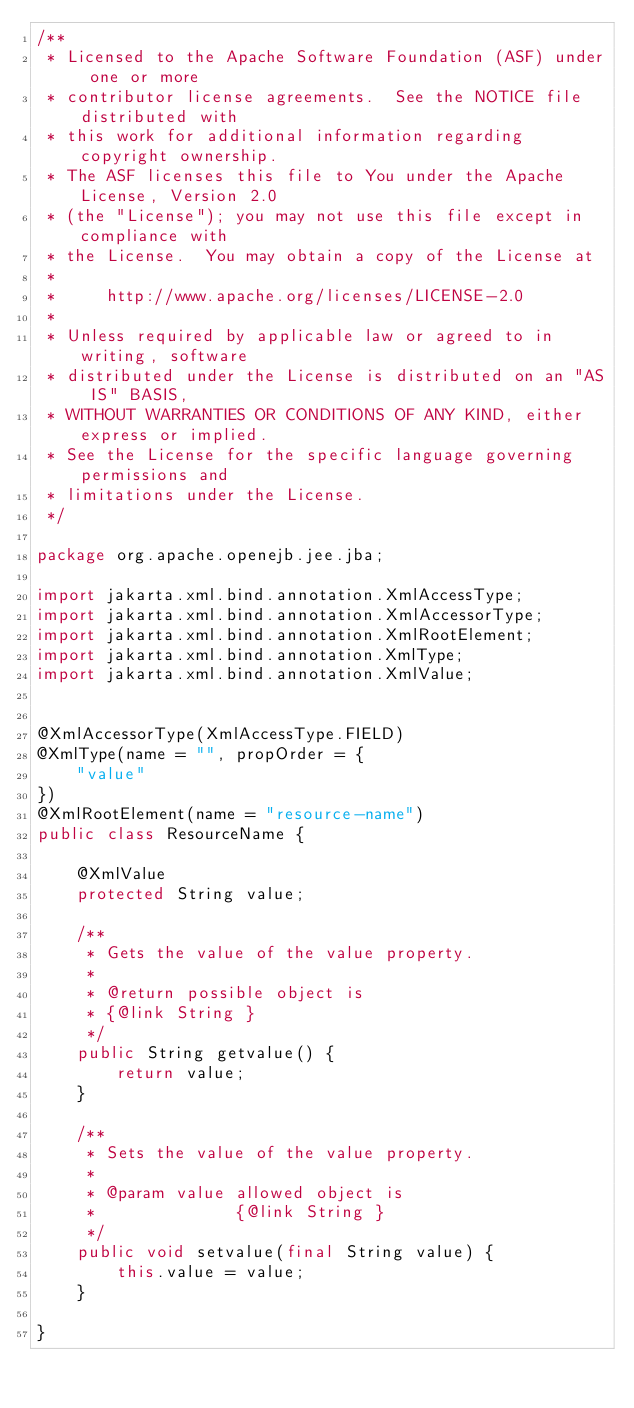Convert code to text. <code><loc_0><loc_0><loc_500><loc_500><_Java_>/**
 * Licensed to the Apache Software Foundation (ASF) under one or more
 * contributor license agreements.  See the NOTICE file distributed with
 * this work for additional information regarding copyright ownership.
 * The ASF licenses this file to You under the Apache License, Version 2.0
 * (the "License"); you may not use this file except in compliance with
 * the License.  You may obtain a copy of the License at
 *
 *     http://www.apache.org/licenses/LICENSE-2.0
 *
 * Unless required by applicable law or agreed to in writing, software
 * distributed under the License is distributed on an "AS IS" BASIS,
 * WITHOUT WARRANTIES OR CONDITIONS OF ANY KIND, either express or implied.
 * See the License for the specific language governing permissions and
 * limitations under the License.
 */

package org.apache.openejb.jee.jba;

import jakarta.xml.bind.annotation.XmlAccessType;
import jakarta.xml.bind.annotation.XmlAccessorType;
import jakarta.xml.bind.annotation.XmlRootElement;
import jakarta.xml.bind.annotation.XmlType;
import jakarta.xml.bind.annotation.XmlValue;


@XmlAccessorType(XmlAccessType.FIELD)
@XmlType(name = "", propOrder = {
    "value"
})
@XmlRootElement(name = "resource-name")
public class ResourceName {

    @XmlValue
    protected String value;

    /**
     * Gets the value of the value property.
     *
     * @return possible object is
     * {@link String }
     */
    public String getvalue() {
        return value;
    }

    /**
     * Sets the value of the value property.
     *
     * @param value allowed object is
     *              {@link String }
     */
    public void setvalue(final String value) {
        this.value = value;
    }

}
</code> 